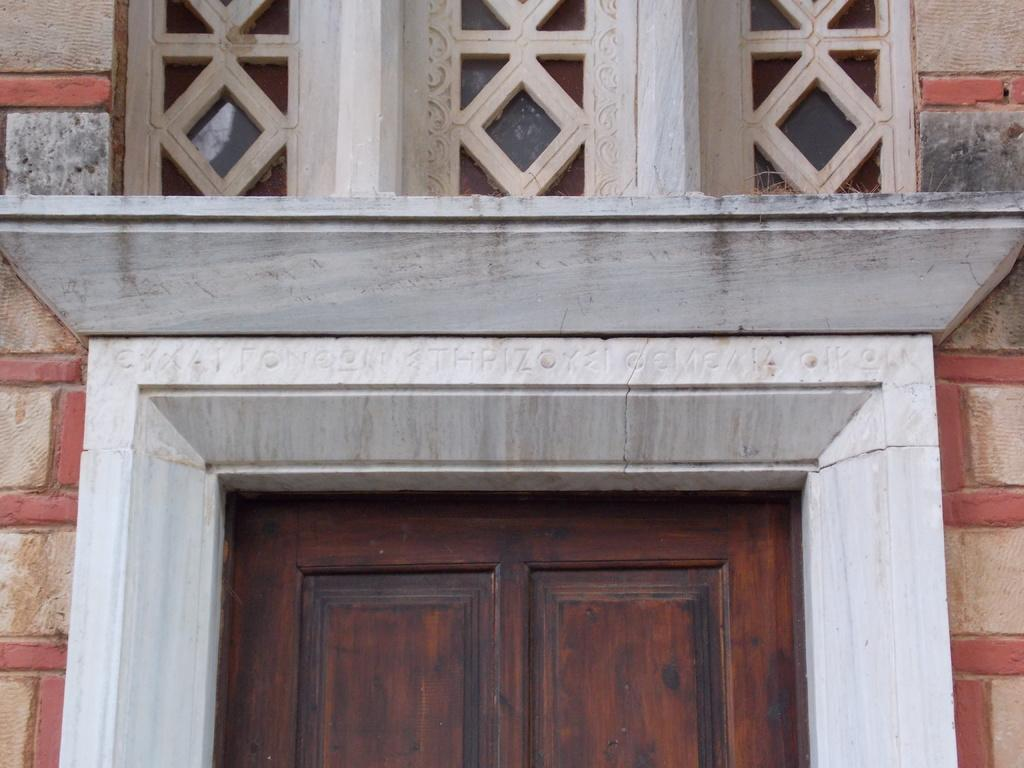What is the main subject in the center of the image? There is a door in the center of the image. What else can be seen in the image besides the door? There is a wall in the image. How does the island contribute to the wealth of the people in the image? There is no island present in the image, and therefore no information about the wealth of the people can be determined. 